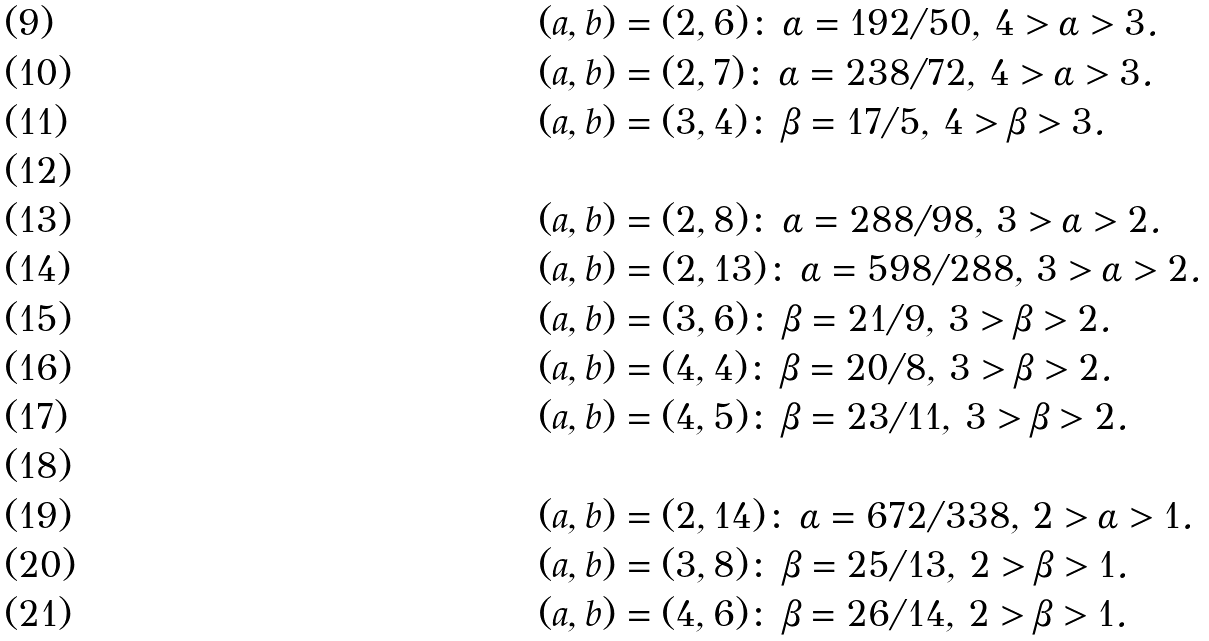Convert formula to latex. <formula><loc_0><loc_0><loc_500><loc_500>& ( a , b ) = ( 2 , 6 ) \colon \, \alpha = 1 9 2 / 5 0 , \, 4 > \alpha > 3 . \\ & ( a , b ) = ( 2 , 7 ) \colon \, \alpha = 2 3 8 / 7 2 , \, 4 > \alpha > 3 . \\ & ( a , b ) = ( 3 , 4 ) \colon \, \beta = 1 7 / 5 , \, 4 > \beta > 3 . \\ & \\ & ( a , b ) = ( 2 , 8 ) \colon \, \alpha = 2 8 8 / 9 8 , \, 3 > \alpha > 2 . \\ & ( a , b ) = ( 2 , 1 3 ) \colon \, \alpha = 5 9 8 / 2 8 8 , \, 3 > \alpha > 2 . \\ & ( a , b ) = ( 3 , 6 ) \colon \, \beta = 2 1 / 9 , \, 3 > \beta > 2 . \\ & ( a , b ) = ( 4 , 4 ) \colon \, \beta = 2 0 / 8 , \, 3 > \beta > 2 . \\ & ( a , b ) = ( 4 , 5 ) \colon \, \beta = 2 3 / 1 1 , \, 3 > \beta > 2 . \\ & \\ & ( a , b ) = ( 2 , 1 4 ) \colon \, \alpha = 6 7 2 / 3 3 8 , \, 2 > \alpha > 1 . \\ & ( a , b ) = ( 3 , 8 ) \colon \, \beta = 2 5 / 1 3 , \, 2 > \beta > 1 . \\ & ( a , b ) = ( 4 , 6 ) \colon \, \beta = 2 6 / 1 4 , \, 2 > \beta > 1 .</formula> 